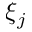<formula> <loc_0><loc_0><loc_500><loc_500>\xi _ { j }</formula> 